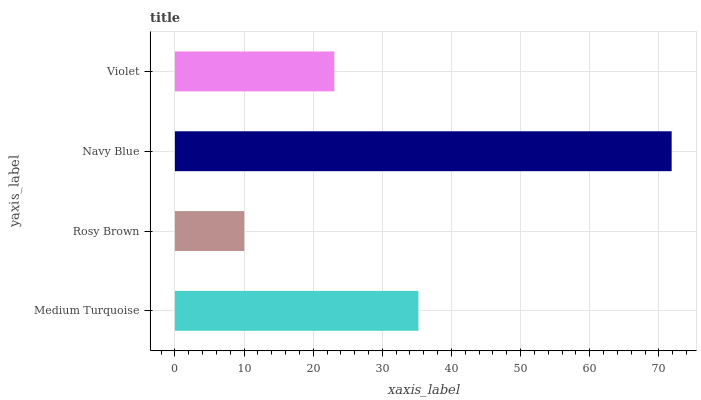Is Rosy Brown the minimum?
Answer yes or no. Yes. Is Navy Blue the maximum?
Answer yes or no. Yes. Is Navy Blue the minimum?
Answer yes or no. No. Is Rosy Brown the maximum?
Answer yes or no. No. Is Navy Blue greater than Rosy Brown?
Answer yes or no. Yes. Is Rosy Brown less than Navy Blue?
Answer yes or no. Yes. Is Rosy Brown greater than Navy Blue?
Answer yes or no. No. Is Navy Blue less than Rosy Brown?
Answer yes or no. No. Is Medium Turquoise the high median?
Answer yes or no. Yes. Is Violet the low median?
Answer yes or no. Yes. Is Rosy Brown the high median?
Answer yes or no. No. Is Navy Blue the low median?
Answer yes or no. No. 